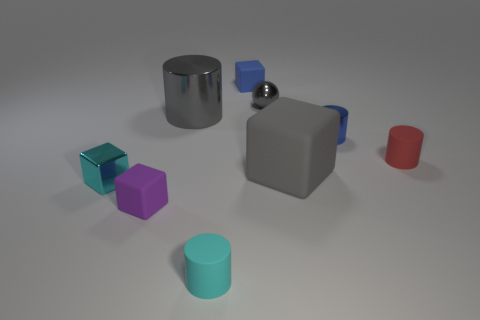How many other things are the same size as the blue metal object?
Your answer should be very brief. 6. There is a cyan object that is the same shape as the red matte object; what size is it?
Keep it short and to the point. Small. There is a rubber object behind the gray cylinder; is its size the same as the metallic cylinder on the right side of the cyan matte cylinder?
Offer a terse response. Yes. What number of small objects are cyan shiny things or cyan matte cylinders?
Your answer should be very brief. 2. How many large gray objects are right of the large gray cylinder and behind the tiny red object?
Offer a very short reply. 0. Is the red thing made of the same material as the big thing that is in front of the small blue cylinder?
Provide a short and direct response. Yes. What number of cyan things are either metallic cubes or spheres?
Your response must be concise. 1. Is there a gray matte block of the same size as the gray cylinder?
Give a very brief answer. Yes. What material is the big gray block in front of the shiny cylinder that is on the right side of the large metal cylinder that is on the left side of the large gray rubber block made of?
Provide a succinct answer. Rubber. Are there an equal number of purple cubes that are to the right of the cyan cylinder and brown cubes?
Provide a short and direct response. Yes. 